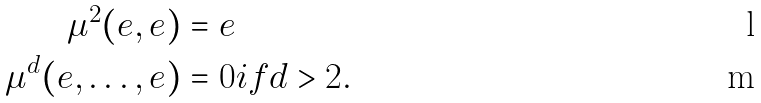<formula> <loc_0><loc_0><loc_500><loc_500>\mu ^ { 2 } ( e , e ) & = e \\ \mu ^ { d } ( e , \dots , e ) & = 0 i f d > 2 .</formula> 